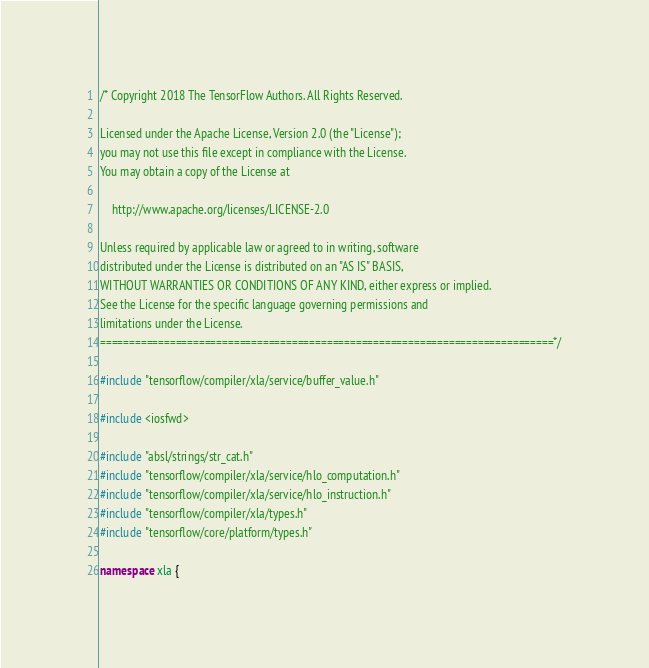<code> <loc_0><loc_0><loc_500><loc_500><_C++_>/* Copyright 2018 The TensorFlow Authors. All Rights Reserved.

Licensed under the Apache License, Version 2.0 (the "License");
you may not use this file except in compliance with the License.
You may obtain a copy of the License at

    http://www.apache.org/licenses/LICENSE-2.0

Unless required by applicable law or agreed to in writing, software
distributed under the License is distributed on an "AS IS" BASIS,
WITHOUT WARRANTIES OR CONDITIONS OF ANY KIND, either express or implied.
See the License for the specific language governing permissions and
limitations under the License.
==============================================================================*/

#include "tensorflow/compiler/xla/service/buffer_value.h"

#include <iosfwd>

#include "absl/strings/str_cat.h"
#include "tensorflow/compiler/xla/service/hlo_computation.h"
#include "tensorflow/compiler/xla/service/hlo_instruction.h"
#include "tensorflow/compiler/xla/types.h"
#include "tensorflow/core/platform/types.h"

namespace xla {
</code> 